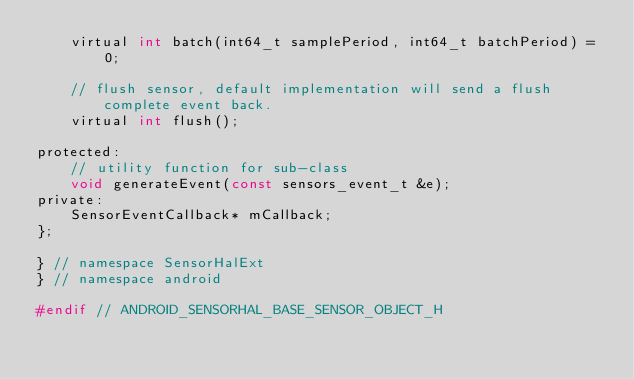<code> <loc_0><loc_0><loc_500><loc_500><_C_>    virtual int batch(int64_t samplePeriod, int64_t batchPeriod) = 0;

    // flush sensor, default implementation will send a flush complete event back.
    virtual int flush();

protected:
    // utility function for sub-class
    void generateEvent(const sensors_event_t &e);
private:
    SensorEventCallback* mCallback;
};

} // namespace SensorHalExt
} // namespace android

#endif // ANDROID_SENSORHAL_BASE_SENSOR_OBJECT_H

</code> 